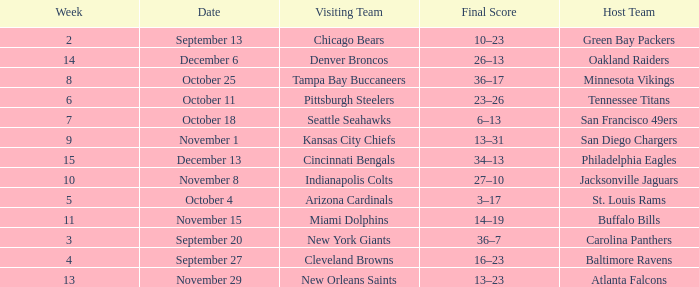What was the final score on week 14 ? 26–13. 